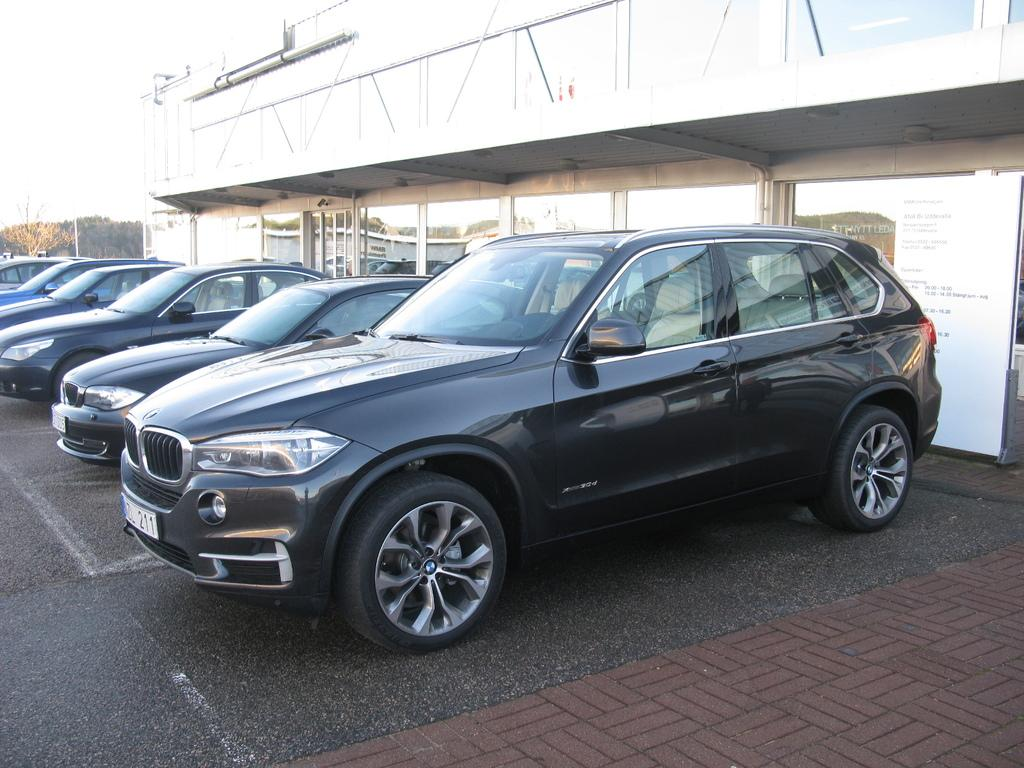What type of vehicles can be seen in the image? There are cars in the image. What is located behind the cars? There is a building behind the cars. What part of the natural environment is visible in the image? The ground and the sky are visible in the image. What type of drink is being served at the car dealership in the image? There is no car dealership or drink present in the image. 